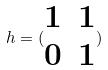<formula> <loc_0><loc_0><loc_500><loc_500>h = ( \begin{matrix} 1 & 1 \\ 0 & 1 \end{matrix} )</formula> 